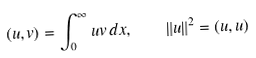<formula> <loc_0><loc_0><loc_500><loc_500>( u , v ) = \int _ { 0 } ^ { \infty } u v \, d x , \quad \| u \| ^ { 2 } = ( u , u )</formula> 